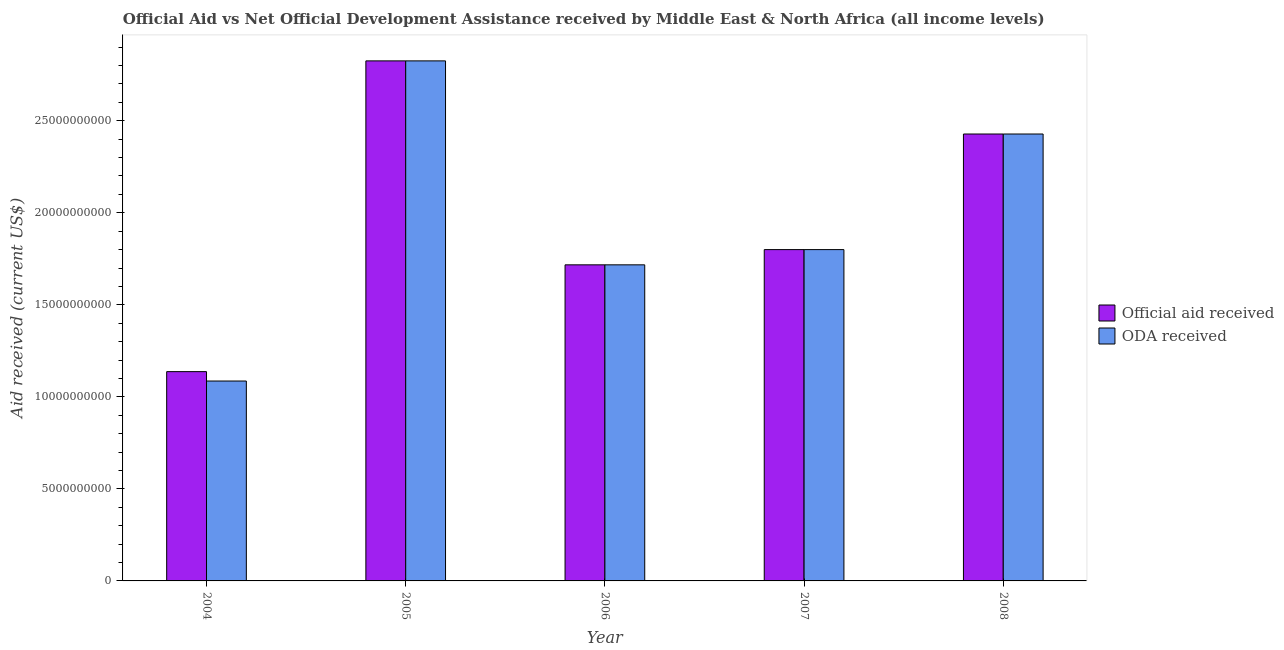Are the number of bars per tick equal to the number of legend labels?
Offer a very short reply. Yes. How many bars are there on the 2nd tick from the left?
Offer a very short reply. 2. In how many cases, is the number of bars for a given year not equal to the number of legend labels?
Make the answer very short. 0. What is the oda received in 2005?
Your answer should be very brief. 2.83e+1. Across all years, what is the maximum official aid received?
Ensure brevity in your answer.  2.83e+1. Across all years, what is the minimum official aid received?
Ensure brevity in your answer.  1.14e+1. What is the total oda received in the graph?
Keep it short and to the point. 9.86e+1. What is the difference between the official aid received in 2005 and that in 2007?
Provide a short and direct response. 1.03e+1. What is the difference between the official aid received in 2005 and the oda received in 2006?
Your answer should be very brief. 1.11e+1. What is the average oda received per year?
Your answer should be compact. 1.97e+1. In the year 2004, what is the difference between the oda received and official aid received?
Make the answer very short. 0. What is the ratio of the oda received in 2004 to that in 2007?
Make the answer very short. 0.6. Is the difference between the official aid received in 2005 and 2007 greater than the difference between the oda received in 2005 and 2007?
Your answer should be very brief. No. What is the difference between the highest and the second highest oda received?
Provide a succinct answer. 3.97e+09. What is the difference between the highest and the lowest official aid received?
Your answer should be very brief. 1.69e+1. Is the sum of the oda received in 2005 and 2007 greater than the maximum official aid received across all years?
Ensure brevity in your answer.  Yes. What does the 2nd bar from the left in 2006 represents?
Your answer should be very brief. ODA received. What does the 1st bar from the right in 2007 represents?
Offer a very short reply. ODA received. Are the values on the major ticks of Y-axis written in scientific E-notation?
Ensure brevity in your answer.  No. Does the graph contain grids?
Ensure brevity in your answer.  No. Where does the legend appear in the graph?
Ensure brevity in your answer.  Center right. What is the title of the graph?
Provide a succinct answer. Official Aid vs Net Official Development Assistance received by Middle East & North Africa (all income levels) . Does "Chemicals" appear as one of the legend labels in the graph?
Provide a short and direct response. No. What is the label or title of the Y-axis?
Provide a succinct answer. Aid received (current US$). What is the Aid received (current US$) in Official aid received in 2004?
Give a very brief answer. 1.14e+1. What is the Aid received (current US$) in ODA received in 2004?
Keep it short and to the point. 1.09e+1. What is the Aid received (current US$) in Official aid received in 2005?
Ensure brevity in your answer.  2.83e+1. What is the Aid received (current US$) in ODA received in 2005?
Ensure brevity in your answer.  2.83e+1. What is the Aid received (current US$) of Official aid received in 2006?
Offer a terse response. 1.72e+1. What is the Aid received (current US$) in ODA received in 2006?
Your answer should be very brief. 1.72e+1. What is the Aid received (current US$) in Official aid received in 2007?
Your response must be concise. 1.80e+1. What is the Aid received (current US$) of ODA received in 2007?
Give a very brief answer. 1.80e+1. What is the Aid received (current US$) in Official aid received in 2008?
Your answer should be compact. 2.43e+1. What is the Aid received (current US$) in ODA received in 2008?
Your response must be concise. 2.43e+1. Across all years, what is the maximum Aid received (current US$) of Official aid received?
Your answer should be very brief. 2.83e+1. Across all years, what is the maximum Aid received (current US$) in ODA received?
Ensure brevity in your answer.  2.83e+1. Across all years, what is the minimum Aid received (current US$) in Official aid received?
Give a very brief answer. 1.14e+1. Across all years, what is the minimum Aid received (current US$) of ODA received?
Make the answer very short. 1.09e+1. What is the total Aid received (current US$) in Official aid received in the graph?
Offer a very short reply. 9.91e+1. What is the total Aid received (current US$) in ODA received in the graph?
Provide a succinct answer. 9.86e+1. What is the difference between the Aid received (current US$) of Official aid received in 2004 and that in 2005?
Provide a short and direct response. -1.69e+1. What is the difference between the Aid received (current US$) of ODA received in 2004 and that in 2005?
Make the answer very short. -1.74e+1. What is the difference between the Aid received (current US$) of Official aid received in 2004 and that in 2006?
Provide a short and direct response. -5.80e+09. What is the difference between the Aid received (current US$) in ODA received in 2004 and that in 2006?
Your answer should be very brief. -6.31e+09. What is the difference between the Aid received (current US$) in Official aid received in 2004 and that in 2007?
Your response must be concise. -6.63e+09. What is the difference between the Aid received (current US$) of ODA received in 2004 and that in 2007?
Make the answer very short. -7.14e+09. What is the difference between the Aid received (current US$) in Official aid received in 2004 and that in 2008?
Your answer should be very brief. -1.29e+1. What is the difference between the Aid received (current US$) of ODA received in 2004 and that in 2008?
Your answer should be compact. -1.34e+1. What is the difference between the Aid received (current US$) of Official aid received in 2005 and that in 2006?
Offer a terse response. 1.11e+1. What is the difference between the Aid received (current US$) in ODA received in 2005 and that in 2006?
Offer a terse response. 1.11e+1. What is the difference between the Aid received (current US$) in Official aid received in 2005 and that in 2007?
Make the answer very short. 1.03e+1. What is the difference between the Aid received (current US$) of ODA received in 2005 and that in 2007?
Give a very brief answer. 1.03e+1. What is the difference between the Aid received (current US$) in Official aid received in 2005 and that in 2008?
Give a very brief answer. 3.97e+09. What is the difference between the Aid received (current US$) of ODA received in 2005 and that in 2008?
Your answer should be compact. 3.97e+09. What is the difference between the Aid received (current US$) in Official aid received in 2006 and that in 2007?
Offer a very short reply. -8.28e+08. What is the difference between the Aid received (current US$) in ODA received in 2006 and that in 2007?
Keep it short and to the point. -8.28e+08. What is the difference between the Aid received (current US$) of Official aid received in 2006 and that in 2008?
Your answer should be very brief. -7.11e+09. What is the difference between the Aid received (current US$) in ODA received in 2006 and that in 2008?
Your response must be concise. -7.11e+09. What is the difference between the Aid received (current US$) of Official aid received in 2007 and that in 2008?
Ensure brevity in your answer.  -6.28e+09. What is the difference between the Aid received (current US$) in ODA received in 2007 and that in 2008?
Provide a succinct answer. -6.28e+09. What is the difference between the Aid received (current US$) of Official aid received in 2004 and the Aid received (current US$) of ODA received in 2005?
Provide a succinct answer. -1.69e+1. What is the difference between the Aid received (current US$) in Official aid received in 2004 and the Aid received (current US$) in ODA received in 2006?
Your answer should be very brief. -5.80e+09. What is the difference between the Aid received (current US$) of Official aid received in 2004 and the Aid received (current US$) of ODA received in 2007?
Your response must be concise. -6.63e+09. What is the difference between the Aid received (current US$) in Official aid received in 2004 and the Aid received (current US$) in ODA received in 2008?
Provide a succinct answer. -1.29e+1. What is the difference between the Aid received (current US$) of Official aid received in 2005 and the Aid received (current US$) of ODA received in 2006?
Give a very brief answer. 1.11e+1. What is the difference between the Aid received (current US$) of Official aid received in 2005 and the Aid received (current US$) of ODA received in 2007?
Your answer should be compact. 1.03e+1. What is the difference between the Aid received (current US$) in Official aid received in 2005 and the Aid received (current US$) in ODA received in 2008?
Ensure brevity in your answer.  3.97e+09. What is the difference between the Aid received (current US$) in Official aid received in 2006 and the Aid received (current US$) in ODA received in 2007?
Offer a very short reply. -8.28e+08. What is the difference between the Aid received (current US$) in Official aid received in 2006 and the Aid received (current US$) in ODA received in 2008?
Offer a terse response. -7.11e+09. What is the difference between the Aid received (current US$) in Official aid received in 2007 and the Aid received (current US$) in ODA received in 2008?
Keep it short and to the point. -6.28e+09. What is the average Aid received (current US$) of Official aid received per year?
Your answer should be very brief. 1.98e+1. What is the average Aid received (current US$) of ODA received per year?
Give a very brief answer. 1.97e+1. In the year 2004, what is the difference between the Aid received (current US$) of Official aid received and Aid received (current US$) of ODA received?
Ensure brevity in your answer.  5.10e+08. In the year 2006, what is the difference between the Aid received (current US$) in Official aid received and Aid received (current US$) in ODA received?
Keep it short and to the point. 0. In the year 2007, what is the difference between the Aid received (current US$) of Official aid received and Aid received (current US$) of ODA received?
Make the answer very short. 0. What is the ratio of the Aid received (current US$) of Official aid received in 2004 to that in 2005?
Offer a very short reply. 0.4. What is the ratio of the Aid received (current US$) in ODA received in 2004 to that in 2005?
Ensure brevity in your answer.  0.38. What is the ratio of the Aid received (current US$) of Official aid received in 2004 to that in 2006?
Ensure brevity in your answer.  0.66. What is the ratio of the Aid received (current US$) of ODA received in 2004 to that in 2006?
Make the answer very short. 0.63. What is the ratio of the Aid received (current US$) in Official aid received in 2004 to that in 2007?
Provide a succinct answer. 0.63. What is the ratio of the Aid received (current US$) of ODA received in 2004 to that in 2007?
Keep it short and to the point. 0.6. What is the ratio of the Aid received (current US$) of Official aid received in 2004 to that in 2008?
Offer a terse response. 0.47. What is the ratio of the Aid received (current US$) in ODA received in 2004 to that in 2008?
Your response must be concise. 0.45. What is the ratio of the Aid received (current US$) of Official aid received in 2005 to that in 2006?
Provide a succinct answer. 1.65. What is the ratio of the Aid received (current US$) of ODA received in 2005 to that in 2006?
Give a very brief answer. 1.65. What is the ratio of the Aid received (current US$) of Official aid received in 2005 to that in 2007?
Provide a succinct answer. 1.57. What is the ratio of the Aid received (current US$) in ODA received in 2005 to that in 2007?
Ensure brevity in your answer.  1.57. What is the ratio of the Aid received (current US$) of Official aid received in 2005 to that in 2008?
Offer a terse response. 1.16. What is the ratio of the Aid received (current US$) of ODA received in 2005 to that in 2008?
Provide a short and direct response. 1.16. What is the ratio of the Aid received (current US$) of Official aid received in 2006 to that in 2007?
Your response must be concise. 0.95. What is the ratio of the Aid received (current US$) in ODA received in 2006 to that in 2007?
Provide a succinct answer. 0.95. What is the ratio of the Aid received (current US$) of Official aid received in 2006 to that in 2008?
Your response must be concise. 0.71. What is the ratio of the Aid received (current US$) in ODA received in 2006 to that in 2008?
Provide a short and direct response. 0.71. What is the ratio of the Aid received (current US$) in Official aid received in 2007 to that in 2008?
Offer a very short reply. 0.74. What is the ratio of the Aid received (current US$) in ODA received in 2007 to that in 2008?
Keep it short and to the point. 0.74. What is the difference between the highest and the second highest Aid received (current US$) of Official aid received?
Your response must be concise. 3.97e+09. What is the difference between the highest and the second highest Aid received (current US$) of ODA received?
Provide a short and direct response. 3.97e+09. What is the difference between the highest and the lowest Aid received (current US$) of Official aid received?
Provide a short and direct response. 1.69e+1. What is the difference between the highest and the lowest Aid received (current US$) in ODA received?
Ensure brevity in your answer.  1.74e+1. 